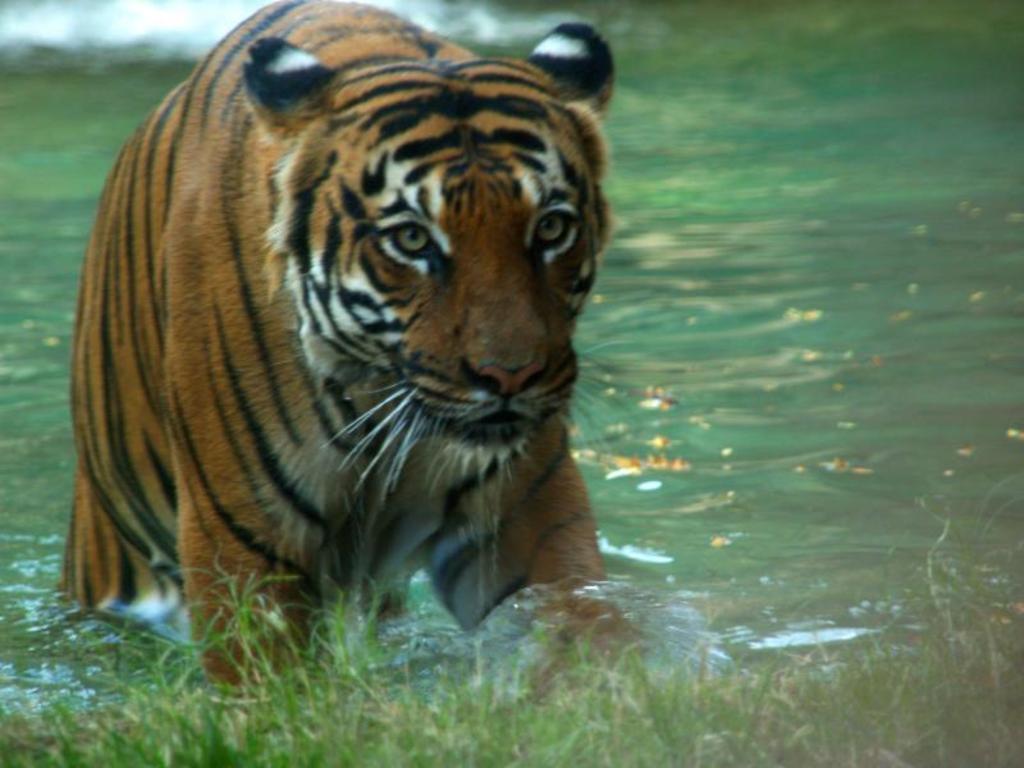Please provide a concise description of this image. In this image I can see the tiger in brown, black and white color. I can see the water and the grass. 